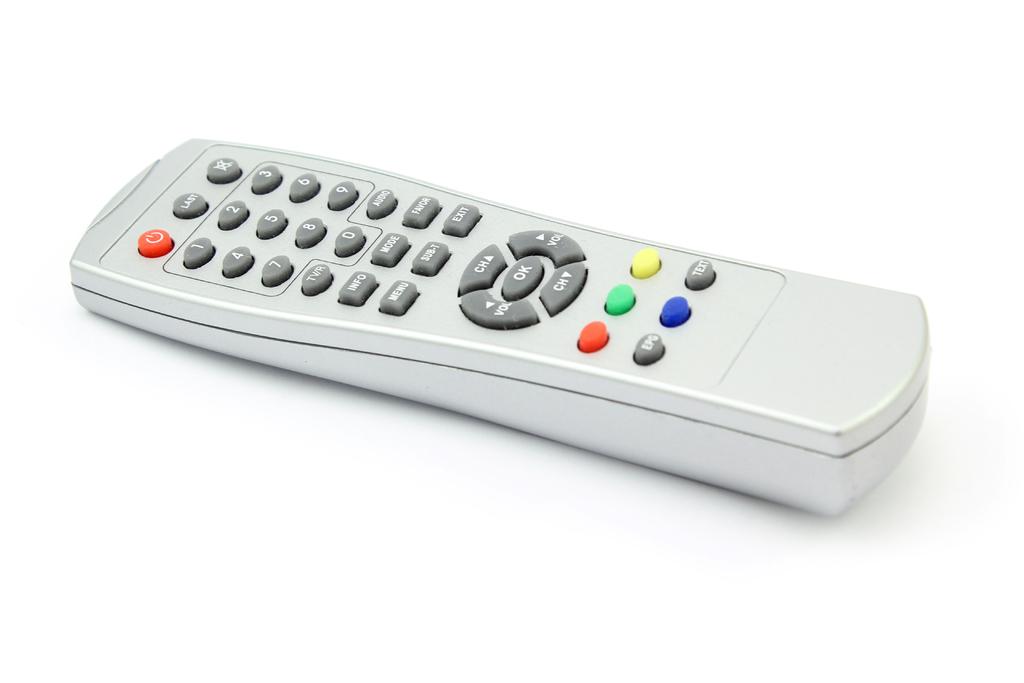What color is the "ok" button?
Make the answer very short. Gray. 